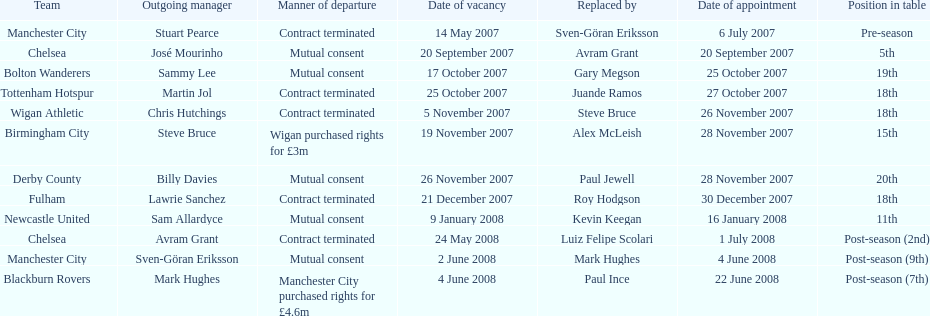Which outgoing manager was appointed the last? Mark Hughes. 